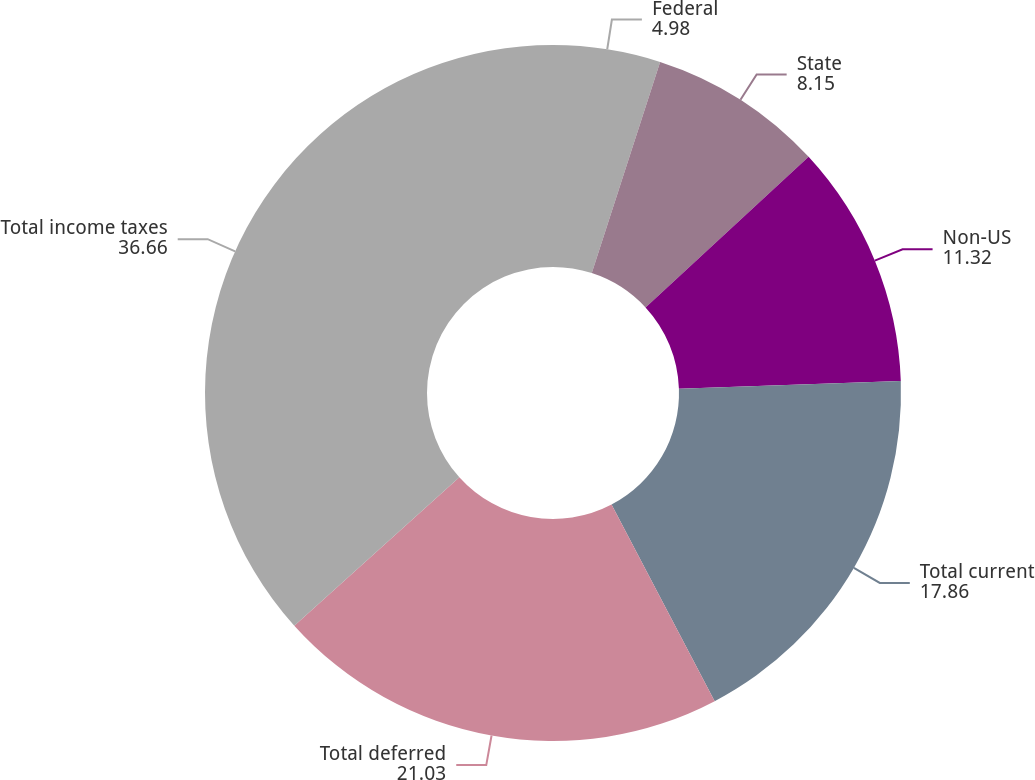Convert chart. <chart><loc_0><loc_0><loc_500><loc_500><pie_chart><fcel>Federal<fcel>State<fcel>Non-US<fcel>Total current<fcel>Total deferred<fcel>Total income taxes<nl><fcel>4.98%<fcel>8.15%<fcel>11.32%<fcel>17.86%<fcel>21.03%<fcel>36.66%<nl></chart> 